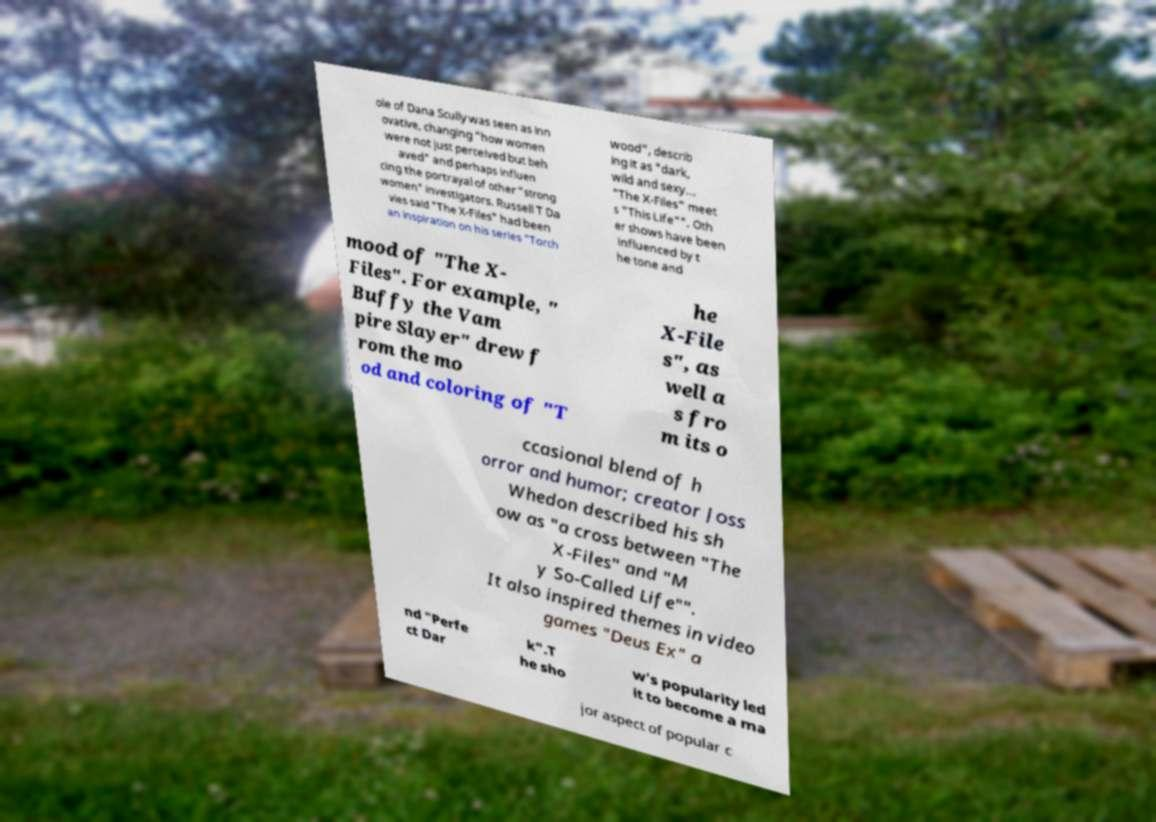What messages or text are displayed in this image? I need them in a readable, typed format. ole of Dana Scully was seen as inn ovative, changing "how women were not just perceived but beh aved" and perhaps influen cing the portrayal of other "strong women" investigators. Russell T Da vies said "The X-Files" had been an inspiration on his series "Torch wood", describ ing it as "dark, wild and sexy... "The X-Files" meet s "This Life"". Oth er shows have been influenced by t he tone and mood of "The X- Files". For example, " Buffy the Vam pire Slayer" drew f rom the mo od and coloring of "T he X-File s", as well a s fro m its o ccasional blend of h orror and humor; creator Joss Whedon described his sh ow as "a cross between "The X-Files" and "M y So-Called Life"". It also inspired themes in video games "Deus Ex" a nd "Perfe ct Dar k".T he sho w's popularity led it to become a ma jor aspect of popular c 